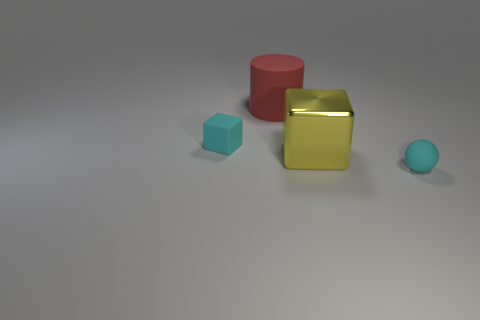Subtract all blue cylinders. Subtract all cyan blocks. How many cylinders are left? 1 Add 2 tiny blue blocks. How many objects exist? 6 Subtract all cylinders. How many objects are left? 3 Add 3 small cyan spheres. How many small cyan spheres are left? 4 Add 2 large red things. How many large red things exist? 3 Subtract 0 brown cubes. How many objects are left? 4 Subtract all small cyan rubber objects. Subtract all big rubber things. How many objects are left? 1 